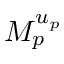<formula> <loc_0><loc_0><loc_500><loc_500>M _ { p } ^ { u _ { p } }</formula> 